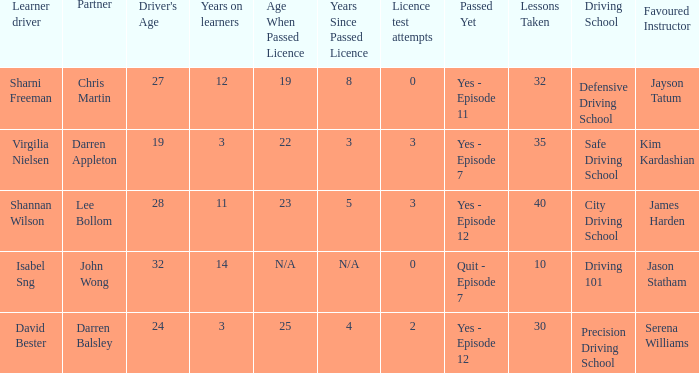What is the average number of years on learners of the drivers over the age of 24 with less than 0 attempts at the licence test? None. 